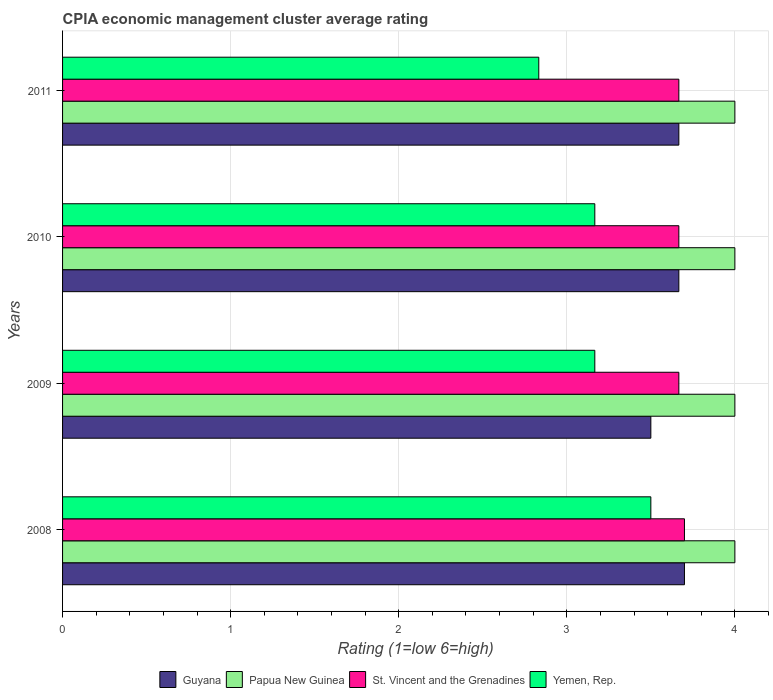How many different coloured bars are there?
Offer a very short reply. 4. How many groups of bars are there?
Give a very brief answer. 4. Are the number of bars on each tick of the Y-axis equal?
Make the answer very short. Yes. What is the label of the 2nd group of bars from the top?
Your answer should be very brief. 2010. What is the CPIA rating in Yemen, Rep. in 2009?
Your response must be concise. 3.17. Across all years, what is the minimum CPIA rating in St. Vincent and the Grenadines?
Provide a succinct answer. 3.67. In which year was the CPIA rating in Guyana minimum?
Give a very brief answer. 2009. What is the total CPIA rating in St. Vincent and the Grenadines in the graph?
Give a very brief answer. 14.7. What is the difference between the CPIA rating in Yemen, Rep. in 2010 and that in 2011?
Offer a very short reply. 0.33. What is the difference between the CPIA rating in Papua New Guinea in 2011 and the CPIA rating in Guyana in 2008?
Provide a short and direct response. 0.3. What is the average CPIA rating in St. Vincent and the Grenadines per year?
Your response must be concise. 3.68. In the year 2008, what is the difference between the CPIA rating in Yemen, Rep. and CPIA rating in St. Vincent and the Grenadines?
Offer a very short reply. -0.2. What is the difference between the highest and the second highest CPIA rating in Papua New Guinea?
Make the answer very short. 0. What is the difference between the highest and the lowest CPIA rating in Guyana?
Your answer should be compact. 0.2. Is the sum of the CPIA rating in Papua New Guinea in 2010 and 2011 greater than the maximum CPIA rating in Guyana across all years?
Keep it short and to the point. Yes. Is it the case that in every year, the sum of the CPIA rating in Guyana and CPIA rating in St. Vincent and the Grenadines is greater than the sum of CPIA rating in Yemen, Rep. and CPIA rating in Papua New Guinea?
Offer a very short reply. No. What does the 3rd bar from the top in 2010 represents?
Your answer should be very brief. Papua New Guinea. What does the 2nd bar from the bottom in 2011 represents?
Offer a terse response. Papua New Guinea. Is it the case that in every year, the sum of the CPIA rating in Yemen, Rep. and CPIA rating in Guyana is greater than the CPIA rating in Papua New Guinea?
Give a very brief answer. Yes. How many bars are there?
Offer a terse response. 16. Are all the bars in the graph horizontal?
Provide a short and direct response. Yes. How many years are there in the graph?
Your answer should be very brief. 4. What is the difference between two consecutive major ticks on the X-axis?
Your answer should be compact. 1. Does the graph contain grids?
Keep it short and to the point. Yes. How are the legend labels stacked?
Provide a short and direct response. Horizontal. What is the title of the graph?
Make the answer very short. CPIA economic management cluster average rating. Does "New Zealand" appear as one of the legend labels in the graph?
Make the answer very short. No. What is the label or title of the X-axis?
Provide a short and direct response. Rating (1=low 6=high). What is the Rating (1=low 6=high) of Papua New Guinea in 2008?
Ensure brevity in your answer.  4. What is the Rating (1=low 6=high) of Guyana in 2009?
Keep it short and to the point. 3.5. What is the Rating (1=low 6=high) in St. Vincent and the Grenadines in 2009?
Ensure brevity in your answer.  3.67. What is the Rating (1=low 6=high) in Yemen, Rep. in 2009?
Make the answer very short. 3.17. What is the Rating (1=low 6=high) in Guyana in 2010?
Offer a very short reply. 3.67. What is the Rating (1=low 6=high) of St. Vincent and the Grenadines in 2010?
Keep it short and to the point. 3.67. What is the Rating (1=low 6=high) in Yemen, Rep. in 2010?
Give a very brief answer. 3.17. What is the Rating (1=low 6=high) in Guyana in 2011?
Offer a very short reply. 3.67. What is the Rating (1=low 6=high) in Papua New Guinea in 2011?
Offer a very short reply. 4. What is the Rating (1=low 6=high) of St. Vincent and the Grenadines in 2011?
Ensure brevity in your answer.  3.67. What is the Rating (1=low 6=high) in Yemen, Rep. in 2011?
Offer a terse response. 2.83. Across all years, what is the maximum Rating (1=low 6=high) in Guyana?
Give a very brief answer. 3.7. Across all years, what is the maximum Rating (1=low 6=high) in Papua New Guinea?
Offer a terse response. 4. Across all years, what is the maximum Rating (1=low 6=high) in Yemen, Rep.?
Offer a very short reply. 3.5. Across all years, what is the minimum Rating (1=low 6=high) in Guyana?
Your response must be concise. 3.5. Across all years, what is the minimum Rating (1=low 6=high) in Papua New Guinea?
Give a very brief answer. 4. Across all years, what is the minimum Rating (1=low 6=high) of St. Vincent and the Grenadines?
Ensure brevity in your answer.  3.67. Across all years, what is the minimum Rating (1=low 6=high) in Yemen, Rep.?
Ensure brevity in your answer.  2.83. What is the total Rating (1=low 6=high) in Guyana in the graph?
Give a very brief answer. 14.53. What is the total Rating (1=low 6=high) in Papua New Guinea in the graph?
Provide a succinct answer. 16. What is the total Rating (1=low 6=high) in St. Vincent and the Grenadines in the graph?
Make the answer very short. 14.7. What is the total Rating (1=low 6=high) of Yemen, Rep. in the graph?
Make the answer very short. 12.67. What is the difference between the Rating (1=low 6=high) of Guyana in 2008 and that in 2009?
Provide a short and direct response. 0.2. What is the difference between the Rating (1=low 6=high) of Papua New Guinea in 2008 and that in 2009?
Offer a terse response. 0. What is the difference between the Rating (1=low 6=high) of Yemen, Rep. in 2008 and that in 2009?
Your answer should be compact. 0.33. What is the difference between the Rating (1=low 6=high) in Guyana in 2008 and that in 2010?
Your answer should be compact. 0.03. What is the difference between the Rating (1=low 6=high) of Papua New Guinea in 2008 and that in 2010?
Your response must be concise. 0. What is the difference between the Rating (1=low 6=high) in St. Vincent and the Grenadines in 2008 and that in 2010?
Provide a short and direct response. 0.03. What is the difference between the Rating (1=low 6=high) in Yemen, Rep. in 2008 and that in 2010?
Ensure brevity in your answer.  0.33. What is the difference between the Rating (1=low 6=high) in Papua New Guinea in 2008 and that in 2011?
Ensure brevity in your answer.  0. What is the difference between the Rating (1=low 6=high) of Yemen, Rep. in 2008 and that in 2011?
Your response must be concise. 0.67. What is the difference between the Rating (1=low 6=high) in Papua New Guinea in 2009 and that in 2010?
Your answer should be compact. 0. What is the difference between the Rating (1=low 6=high) in Yemen, Rep. in 2009 and that in 2010?
Your response must be concise. 0. What is the difference between the Rating (1=low 6=high) of Papua New Guinea in 2009 and that in 2011?
Keep it short and to the point. 0. What is the difference between the Rating (1=low 6=high) of Yemen, Rep. in 2009 and that in 2011?
Provide a short and direct response. 0.33. What is the difference between the Rating (1=low 6=high) of Guyana in 2010 and that in 2011?
Keep it short and to the point. 0. What is the difference between the Rating (1=low 6=high) in Papua New Guinea in 2010 and that in 2011?
Make the answer very short. 0. What is the difference between the Rating (1=low 6=high) in St. Vincent and the Grenadines in 2010 and that in 2011?
Give a very brief answer. 0. What is the difference between the Rating (1=low 6=high) in Guyana in 2008 and the Rating (1=low 6=high) in Yemen, Rep. in 2009?
Keep it short and to the point. 0.53. What is the difference between the Rating (1=low 6=high) in Papua New Guinea in 2008 and the Rating (1=low 6=high) in Yemen, Rep. in 2009?
Offer a very short reply. 0.83. What is the difference between the Rating (1=low 6=high) in St. Vincent and the Grenadines in 2008 and the Rating (1=low 6=high) in Yemen, Rep. in 2009?
Keep it short and to the point. 0.53. What is the difference between the Rating (1=low 6=high) in Guyana in 2008 and the Rating (1=low 6=high) in Papua New Guinea in 2010?
Offer a terse response. -0.3. What is the difference between the Rating (1=low 6=high) of Guyana in 2008 and the Rating (1=low 6=high) of Yemen, Rep. in 2010?
Provide a short and direct response. 0.53. What is the difference between the Rating (1=low 6=high) in Papua New Guinea in 2008 and the Rating (1=low 6=high) in St. Vincent and the Grenadines in 2010?
Give a very brief answer. 0.33. What is the difference between the Rating (1=low 6=high) of Papua New Guinea in 2008 and the Rating (1=low 6=high) of Yemen, Rep. in 2010?
Ensure brevity in your answer.  0.83. What is the difference between the Rating (1=low 6=high) in St. Vincent and the Grenadines in 2008 and the Rating (1=low 6=high) in Yemen, Rep. in 2010?
Give a very brief answer. 0.53. What is the difference between the Rating (1=low 6=high) in Guyana in 2008 and the Rating (1=low 6=high) in Papua New Guinea in 2011?
Ensure brevity in your answer.  -0.3. What is the difference between the Rating (1=low 6=high) in Guyana in 2008 and the Rating (1=low 6=high) in Yemen, Rep. in 2011?
Offer a very short reply. 0.87. What is the difference between the Rating (1=low 6=high) of Papua New Guinea in 2008 and the Rating (1=low 6=high) of St. Vincent and the Grenadines in 2011?
Offer a very short reply. 0.33. What is the difference between the Rating (1=low 6=high) in St. Vincent and the Grenadines in 2008 and the Rating (1=low 6=high) in Yemen, Rep. in 2011?
Offer a very short reply. 0.87. What is the difference between the Rating (1=low 6=high) of Guyana in 2009 and the Rating (1=low 6=high) of Yemen, Rep. in 2010?
Provide a succinct answer. 0.33. What is the difference between the Rating (1=low 6=high) in St. Vincent and the Grenadines in 2009 and the Rating (1=low 6=high) in Yemen, Rep. in 2010?
Your answer should be compact. 0.5. What is the difference between the Rating (1=low 6=high) in Guyana in 2009 and the Rating (1=low 6=high) in Papua New Guinea in 2011?
Your answer should be compact. -0.5. What is the difference between the Rating (1=low 6=high) in Guyana in 2009 and the Rating (1=low 6=high) in St. Vincent and the Grenadines in 2011?
Offer a very short reply. -0.17. What is the difference between the Rating (1=low 6=high) of Guyana in 2009 and the Rating (1=low 6=high) of Yemen, Rep. in 2011?
Provide a succinct answer. 0.67. What is the difference between the Rating (1=low 6=high) in Papua New Guinea in 2009 and the Rating (1=low 6=high) in Yemen, Rep. in 2011?
Keep it short and to the point. 1.17. What is the difference between the Rating (1=low 6=high) in Guyana in 2010 and the Rating (1=low 6=high) in St. Vincent and the Grenadines in 2011?
Your answer should be compact. 0. What is the difference between the Rating (1=low 6=high) of Guyana in 2010 and the Rating (1=low 6=high) of Yemen, Rep. in 2011?
Make the answer very short. 0.83. What is the difference between the Rating (1=low 6=high) of Papua New Guinea in 2010 and the Rating (1=low 6=high) of St. Vincent and the Grenadines in 2011?
Your answer should be very brief. 0.33. What is the difference between the Rating (1=low 6=high) in Papua New Guinea in 2010 and the Rating (1=low 6=high) in Yemen, Rep. in 2011?
Your answer should be very brief. 1.17. What is the average Rating (1=low 6=high) in Guyana per year?
Ensure brevity in your answer.  3.63. What is the average Rating (1=low 6=high) in St. Vincent and the Grenadines per year?
Provide a succinct answer. 3.67. What is the average Rating (1=low 6=high) in Yemen, Rep. per year?
Your response must be concise. 3.17. In the year 2008, what is the difference between the Rating (1=low 6=high) in Guyana and Rating (1=low 6=high) in Papua New Guinea?
Give a very brief answer. -0.3. In the year 2008, what is the difference between the Rating (1=low 6=high) of Guyana and Rating (1=low 6=high) of St. Vincent and the Grenadines?
Provide a short and direct response. 0. In the year 2008, what is the difference between the Rating (1=low 6=high) of Papua New Guinea and Rating (1=low 6=high) of St. Vincent and the Grenadines?
Offer a terse response. 0.3. In the year 2008, what is the difference between the Rating (1=low 6=high) of Papua New Guinea and Rating (1=low 6=high) of Yemen, Rep.?
Offer a very short reply. 0.5. In the year 2008, what is the difference between the Rating (1=low 6=high) of St. Vincent and the Grenadines and Rating (1=low 6=high) of Yemen, Rep.?
Provide a short and direct response. 0.2. In the year 2009, what is the difference between the Rating (1=low 6=high) of Guyana and Rating (1=low 6=high) of St. Vincent and the Grenadines?
Offer a very short reply. -0.17. In the year 2009, what is the difference between the Rating (1=low 6=high) of Papua New Guinea and Rating (1=low 6=high) of Yemen, Rep.?
Provide a short and direct response. 0.83. In the year 2009, what is the difference between the Rating (1=low 6=high) of St. Vincent and the Grenadines and Rating (1=low 6=high) of Yemen, Rep.?
Your answer should be compact. 0.5. In the year 2010, what is the difference between the Rating (1=low 6=high) in Guyana and Rating (1=low 6=high) in Yemen, Rep.?
Provide a succinct answer. 0.5. In the year 2010, what is the difference between the Rating (1=low 6=high) in St. Vincent and the Grenadines and Rating (1=low 6=high) in Yemen, Rep.?
Provide a succinct answer. 0.5. In the year 2011, what is the difference between the Rating (1=low 6=high) in Guyana and Rating (1=low 6=high) in Papua New Guinea?
Offer a terse response. -0.33. In the year 2011, what is the difference between the Rating (1=low 6=high) in Guyana and Rating (1=low 6=high) in Yemen, Rep.?
Provide a succinct answer. 0.83. In the year 2011, what is the difference between the Rating (1=low 6=high) in Papua New Guinea and Rating (1=low 6=high) in St. Vincent and the Grenadines?
Make the answer very short. 0.33. In the year 2011, what is the difference between the Rating (1=low 6=high) of St. Vincent and the Grenadines and Rating (1=low 6=high) of Yemen, Rep.?
Provide a succinct answer. 0.83. What is the ratio of the Rating (1=low 6=high) in Guyana in 2008 to that in 2009?
Provide a short and direct response. 1.06. What is the ratio of the Rating (1=low 6=high) of Papua New Guinea in 2008 to that in 2009?
Offer a terse response. 1. What is the ratio of the Rating (1=low 6=high) in St. Vincent and the Grenadines in 2008 to that in 2009?
Ensure brevity in your answer.  1.01. What is the ratio of the Rating (1=low 6=high) in Yemen, Rep. in 2008 to that in 2009?
Your response must be concise. 1.11. What is the ratio of the Rating (1=low 6=high) of Guyana in 2008 to that in 2010?
Keep it short and to the point. 1.01. What is the ratio of the Rating (1=low 6=high) in Papua New Guinea in 2008 to that in 2010?
Keep it short and to the point. 1. What is the ratio of the Rating (1=low 6=high) in St. Vincent and the Grenadines in 2008 to that in 2010?
Provide a succinct answer. 1.01. What is the ratio of the Rating (1=low 6=high) of Yemen, Rep. in 2008 to that in 2010?
Provide a succinct answer. 1.11. What is the ratio of the Rating (1=low 6=high) in Guyana in 2008 to that in 2011?
Keep it short and to the point. 1.01. What is the ratio of the Rating (1=low 6=high) in St. Vincent and the Grenadines in 2008 to that in 2011?
Provide a succinct answer. 1.01. What is the ratio of the Rating (1=low 6=high) in Yemen, Rep. in 2008 to that in 2011?
Provide a short and direct response. 1.24. What is the ratio of the Rating (1=low 6=high) in Guyana in 2009 to that in 2010?
Give a very brief answer. 0.95. What is the ratio of the Rating (1=low 6=high) in St. Vincent and the Grenadines in 2009 to that in 2010?
Your response must be concise. 1. What is the ratio of the Rating (1=low 6=high) in Yemen, Rep. in 2009 to that in 2010?
Ensure brevity in your answer.  1. What is the ratio of the Rating (1=low 6=high) of Guyana in 2009 to that in 2011?
Give a very brief answer. 0.95. What is the ratio of the Rating (1=low 6=high) of Papua New Guinea in 2009 to that in 2011?
Provide a short and direct response. 1. What is the ratio of the Rating (1=low 6=high) in St. Vincent and the Grenadines in 2009 to that in 2011?
Provide a succinct answer. 1. What is the ratio of the Rating (1=low 6=high) in Yemen, Rep. in 2009 to that in 2011?
Your response must be concise. 1.12. What is the ratio of the Rating (1=low 6=high) of Guyana in 2010 to that in 2011?
Your answer should be very brief. 1. What is the ratio of the Rating (1=low 6=high) of St. Vincent and the Grenadines in 2010 to that in 2011?
Your answer should be very brief. 1. What is the ratio of the Rating (1=low 6=high) of Yemen, Rep. in 2010 to that in 2011?
Ensure brevity in your answer.  1.12. What is the difference between the highest and the second highest Rating (1=low 6=high) in St. Vincent and the Grenadines?
Give a very brief answer. 0.03. What is the difference between the highest and the lowest Rating (1=low 6=high) of Guyana?
Offer a terse response. 0.2. What is the difference between the highest and the lowest Rating (1=low 6=high) in St. Vincent and the Grenadines?
Ensure brevity in your answer.  0.03. What is the difference between the highest and the lowest Rating (1=low 6=high) of Yemen, Rep.?
Keep it short and to the point. 0.67. 